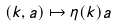Convert formula to latex. <formula><loc_0><loc_0><loc_500><loc_500>( k , a ) \mapsto \eta ( k ) a</formula> 